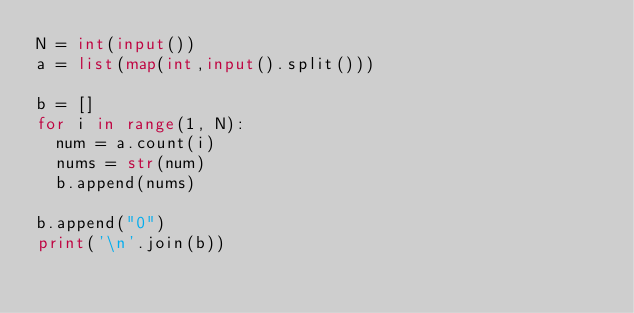Convert code to text. <code><loc_0><loc_0><loc_500><loc_500><_Python_>N = int(input())
a = list(map(int,input().split()))

b = []
for i in range(1, N):
  num = a.count(i)
  nums = str(num)
  b.append(nums)

b.append("0")
print('\n'.join(b))</code> 